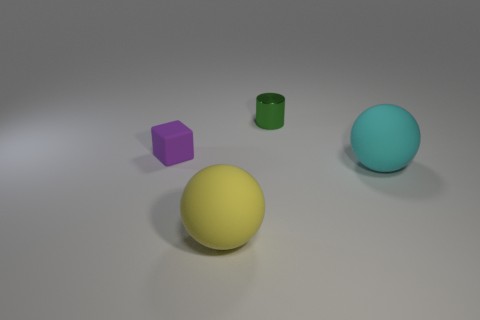Add 2 small yellow cylinders. How many objects exist? 6 Subtract all cylinders. How many objects are left? 3 Add 3 metal objects. How many metal objects exist? 4 Subtract 0 gray cubes. How many objects are left? 4 Subtract all small metal cylinders. Subtract all big yellow spheres. How many objects are left? 2 Add 4 small green metallic cylinders. How many small green metallic cylinders are left? 5 